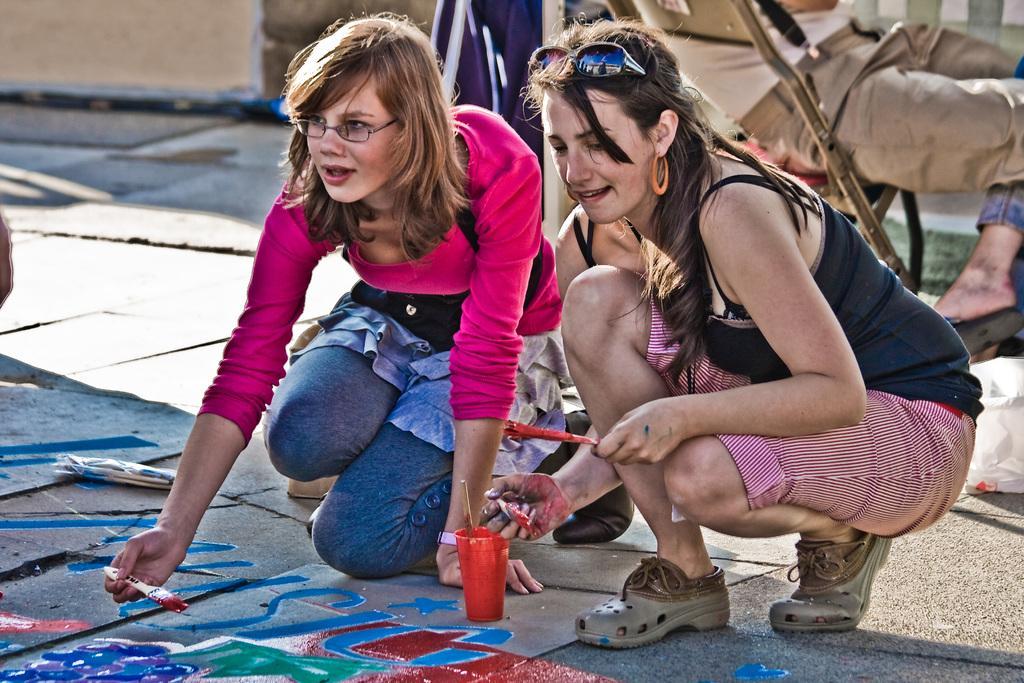Can you describe this image briefly? In the center of the image two ladies are sitting on their knees and holding brush in there hands. In the background of the image we can see some persons, road, plastic cover are there. At the top of the image wall is there. At the bottom of the image some painting is there. 